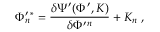<formula> <loc_0><loc_0><loc_500><loc_500>\Phi _ { n } ^ { \prime ^ { * } = \frac { \delta \Psi ^ { \prime } ( \Phi ^ { \prime } , K ) } { \delta \Phi ^ { \prime ^ { n } } + K _ { n } \, ,</formula> 